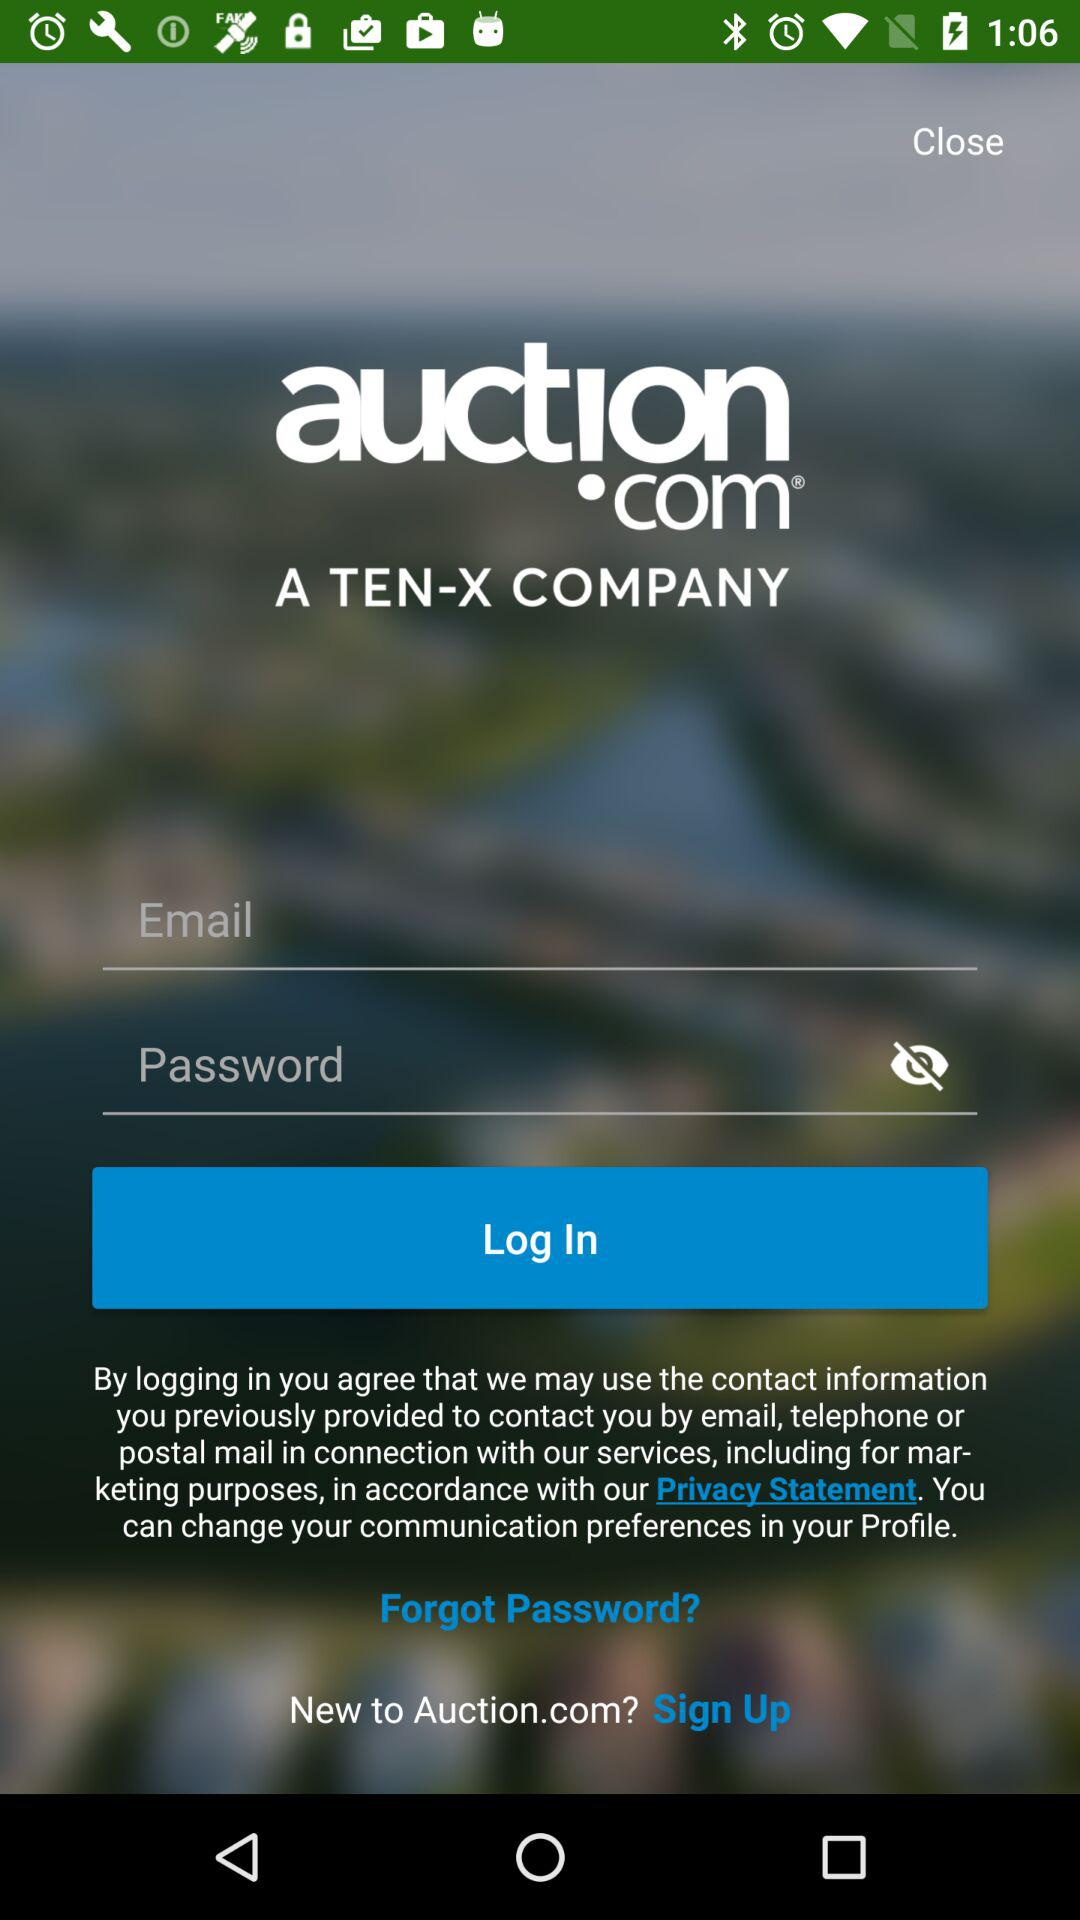What is the app name? The app name is "auction.com". 